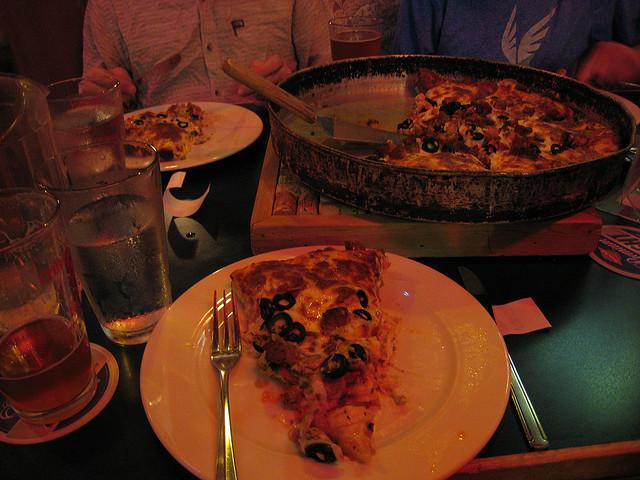What is on the pizza? Please explain your reasoning. olives. There are black objects on the pizza. 